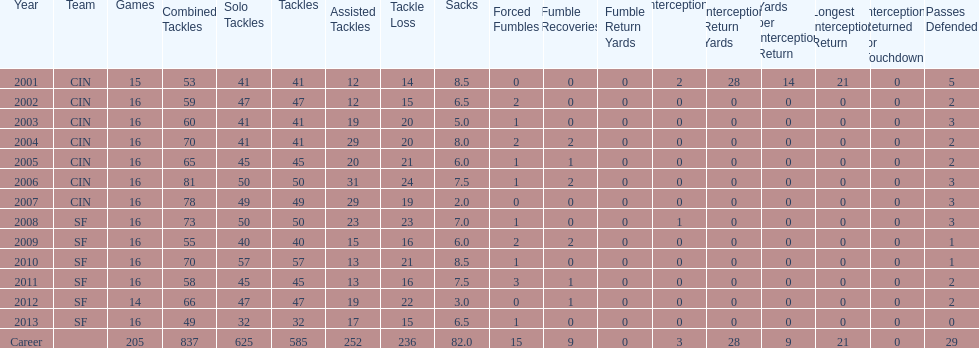What is the only season he has fewer than three sacks? 2007. Can you parse all the data within this table? {'header': ['Year', 'Team', 'Games', 'Combined Tackles', 'Solo Tackles', 'Tackles', 'Assisted Tackles', 'Tackle Loss', 'Sacks', 'Forced Fumbles', 'Fumble Recoveries', 'Fumble Return Yards', 'Interceptions', 'Interception Return Yards', 'Yards per Interception Return', 'Longest Interception Return', 'Interceptions Returned for Touchdown', 'Passes Defended'], 'rows': [['2001', 'CIN', '15', '53', '41', '41', '12', '14', '8.5', '0', '0', '0', '2', '28', '14', '21', '0', '5'], ['2002', 'CIN', '16', '59', '47', '47', '12', '15', '6.5', '2', '0', '0', '0', '0', '0', '0', '0', '2'], ['2003', 'CIN', '16', '60', '41', '41', '19', '20', '5.0', '1', '0', '0', '0', '0', '0', '0', '0', '3'], ['2004', 'CIN', '16', '70', '41', '41', '29', '20', '8.0', '2', '2', '0', '0', '0', '0', '0', '0', '2'], ['2005', 'CIN', '16', '65', '45', '45', '20', '21', '6.0', '1', '1', '0', '0', '0', '0', '0', '0', '2'], ['2006', 'CIN', '16', '81', '50', '50', '31', '24', '7.5', '1', '2', '0', '0', '0', '0', '0', '0', '3'], ['2007', 'CIN', '16', '78', '49', '49', '29', '19', '2.0', '0', '0', '0', '0', '0', '0', '0', '0', '3'], ['2008', 'SF', '16', '73', '50', '50', '23', '23', '7.0', '1', '0', '0', '1', '0', '0', '0', '0', '3'], ['2009', 'SF', '16', '55', '40', '40', '15', '16', '6.0', '2', '2', '0', '0', '0', '0', '0', '0', '1'], ['2010', 'SF', '16', '70', '57', '57', '13', '21', '8.5', '1', '0', '0', '0', '0', '0', '0', '0', '1'], ['2011', 'SF', '16', '58', '45', '45', '13', '16', '7.5', '3', '1', '0', '0', '0', '0', '0', '0', '2'], ['2012', 'SF', '14', '66', '47', '47', '19', '22', '3.0', '0', '1', '0', '0', '0', '0', '0', '0', '2'], ['2013', 'SF', '16', '49', '32', '32', '17', '15', '6.5', '1', '0', '0', '0', '0', '0', '0', '0', '0'], ['Career', '', '205', '837', '625', '585', '252', '236', '82.0', '15', '9', '0', '3', '28', '9', '21', '0', '29']]} 